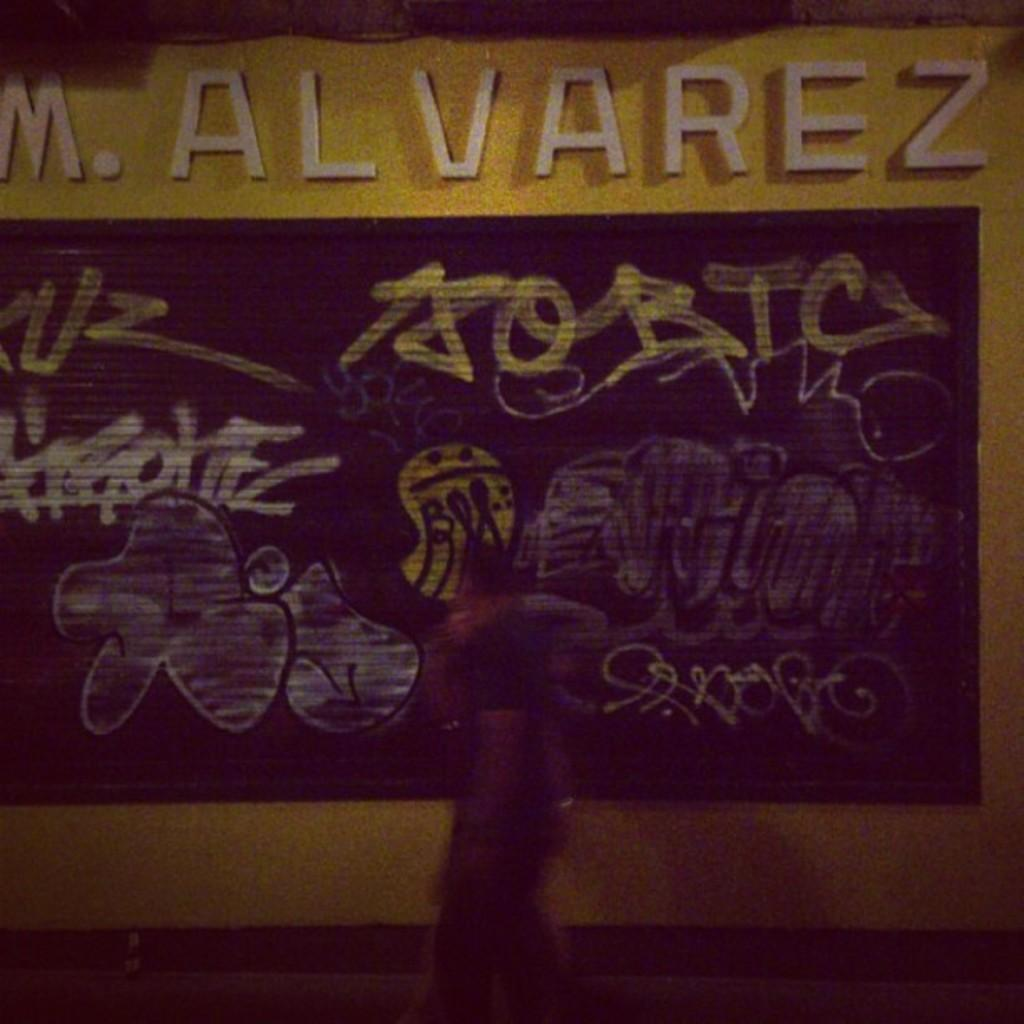What is the main subject of the image? There is a person walking in the image. What can be seen in the background of the image? There is a poster on the wall in the background. What is written or depicted on the poster? There is text visible on the poster. What type of operation is being performed on the stage in the image? There is no stage or operation present in the image; it features a person walking and a poster on the wall. 